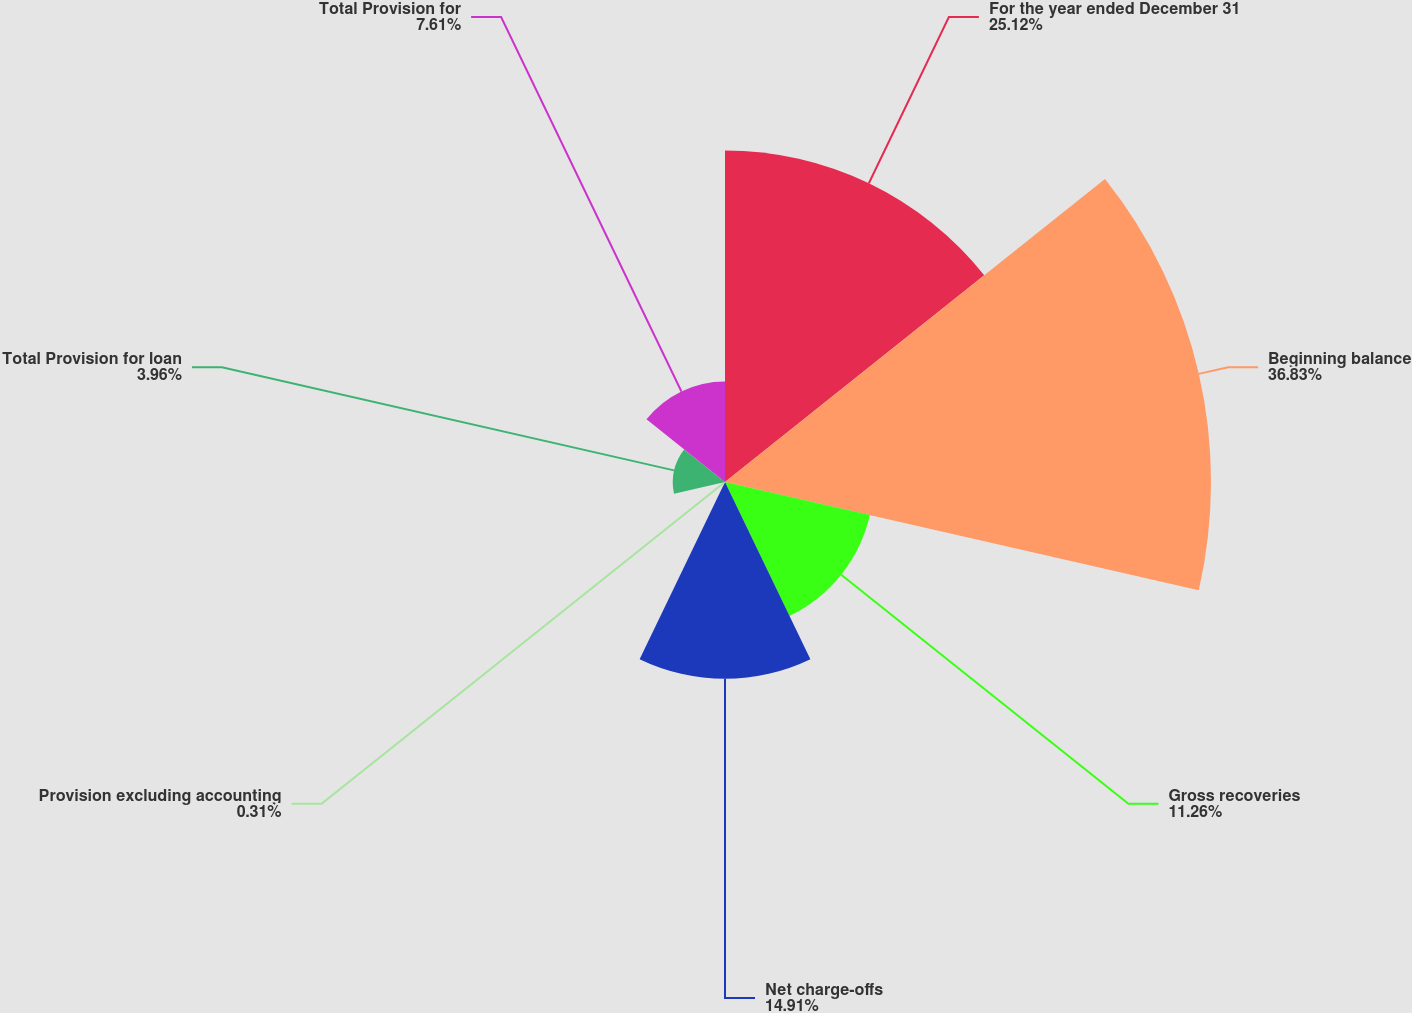Convert chart to OTSL. <chart><loc_0><loc_0><loc_500><loc_500><pie_chart><fcel>For the year ended December 31<fcel>Beginning balance<fcel>Gross recoveries<fcel>Net charge-offs<fcel>Provision excluding accounting<fcel>Total Provision for loan<fcel>Total Provision for<nl><fcel>25.12%<fcel>36.82%<fcel>11.26%<fcel>14.91%<fcel>0.31%<fcel>3.96%<fcel>7.61%<nl></chart> 